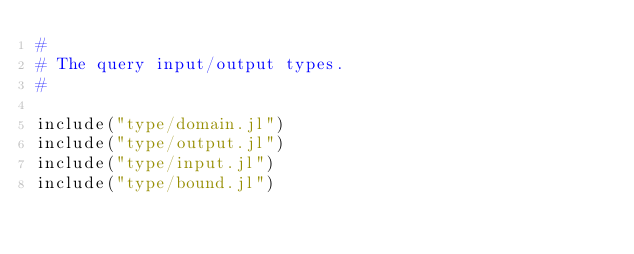Convert code to text. <code><loc_0><loc_0><loc_500><loc_500><_Julia_>#
# The query input/output types.
#

include("type/domain.jl")
include("type/output.jl")
include("type/input.jl")
include("type/bound.jl")

</code> 